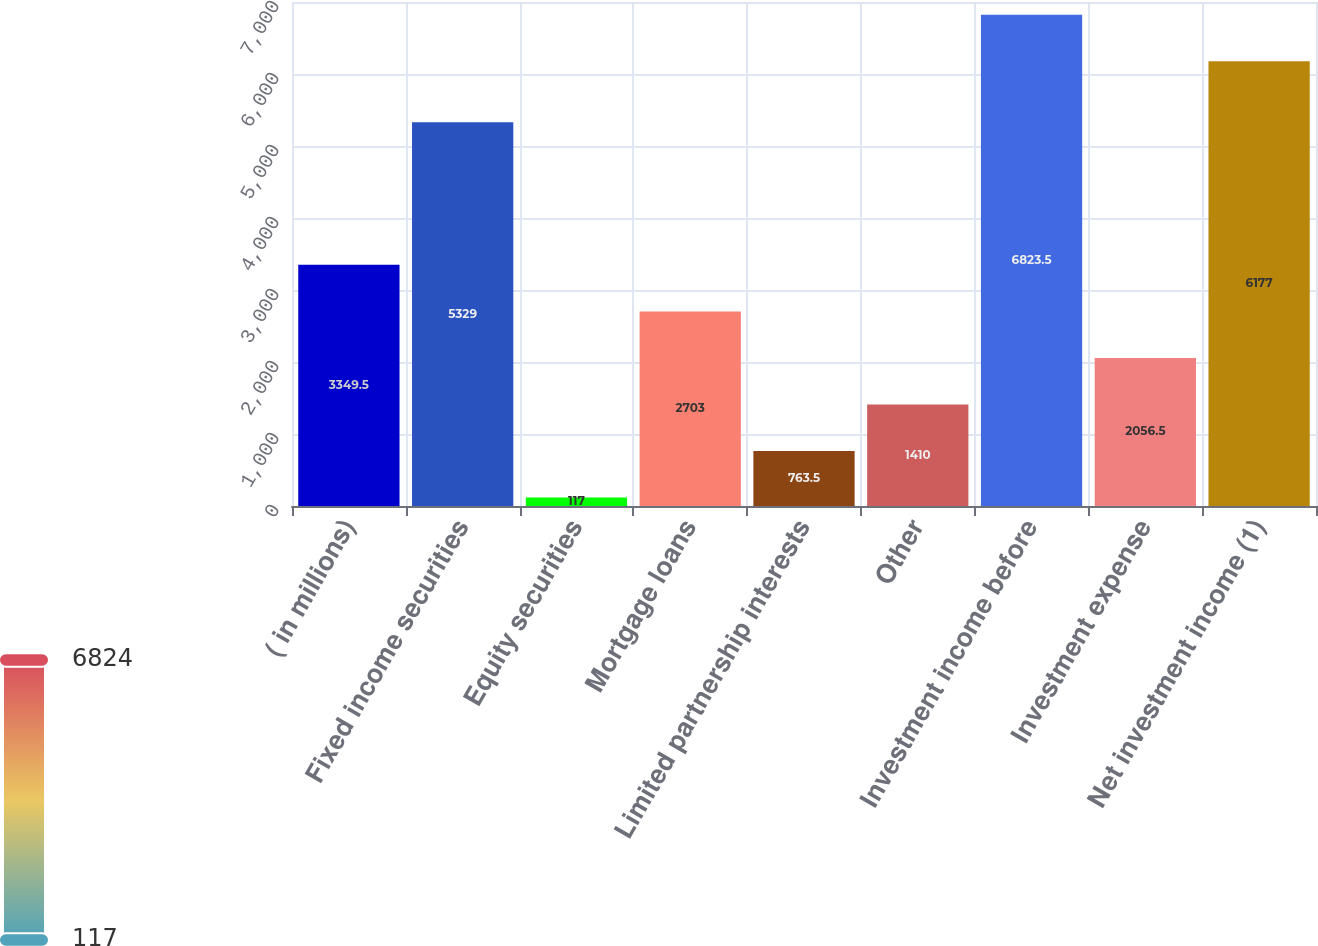Convert chart to OTSL. <chart><loc_0><loc_0><loc_500><loc_500><bar_chart><fcel>( in millions)<fcel>Fixed income securities<fcel>Equity securities<fcel>Mortgage loans<fcel>Limited partnership interests<fcel>Other<fcel>Investment income before<fcel>Investment expense<fcel>Net investment income (1)<nl><fcel>3349.5<fcel>5329<fcel>117<fcel>2703<fcel>763.5<fcel>1410<fcel>6823.5<fcel>2056.5<fcel>6177<nl></chart> 